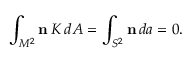Convert formula to latex. <formula><loc_0><loc_0><loc_500><loc_500>\int _ { M ^ { 2 } } { n } \, K \, d A = \int _ { S ^ { 2 } } { n } \, d a = 0 .</formula> 